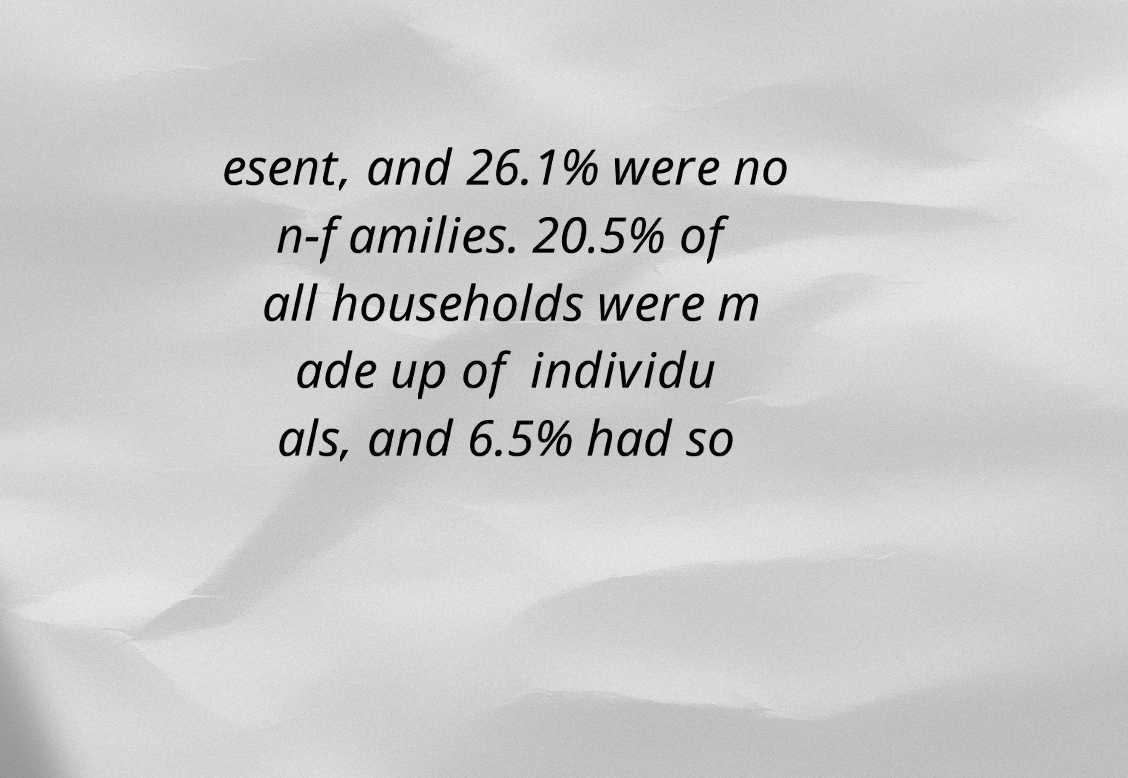Could you extract and type out the text from this image? esent, and 26.1% were no n-families. 20.5% of all households were m ade up of individu als, and 6.5% had so 